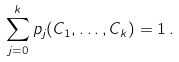<formula> <loc_0><loc_0><loc_500><loc_500>\sum _ { j = 0 } ^ { k } p _ { j } ( C _ { 1 } , \dots , C _ { k } ) = 1 \, .</formula> 